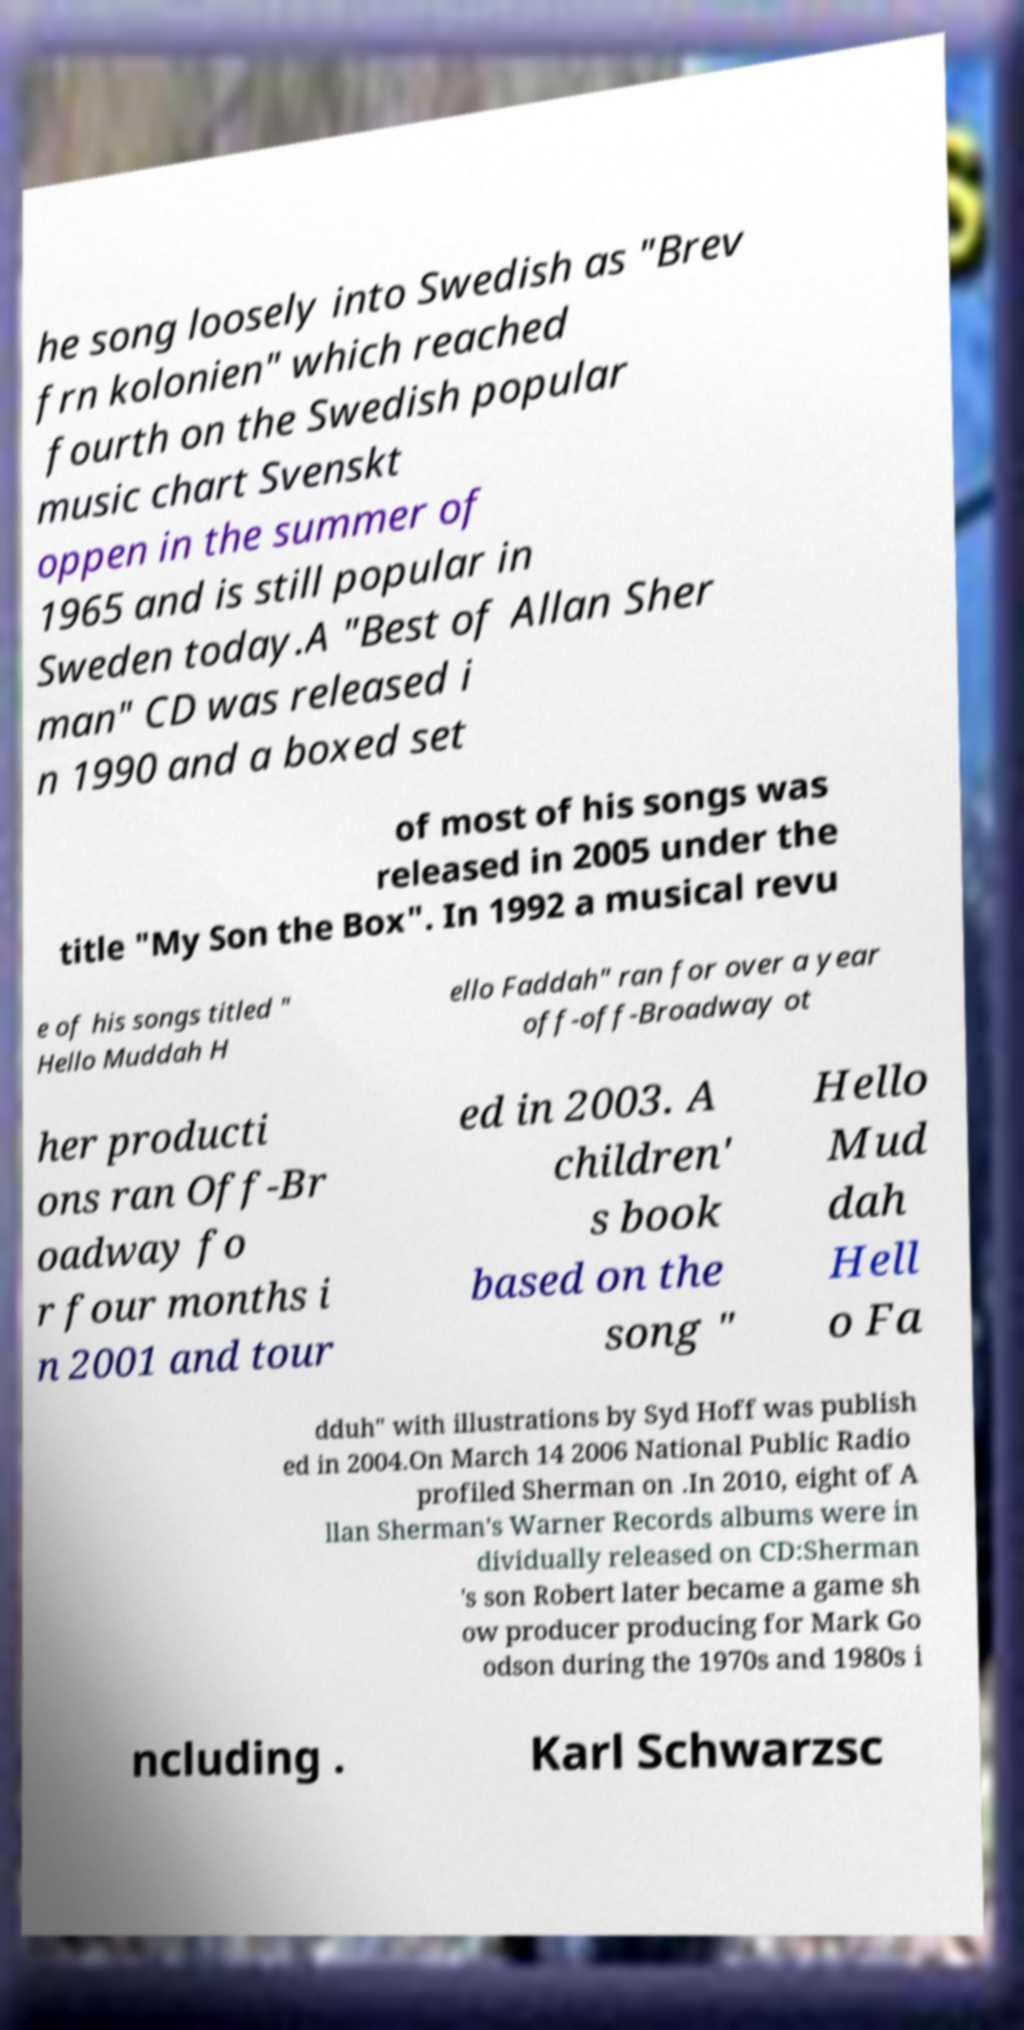Please read and relay the text visible in this image. What does it say? he song loosely into Swedish as "Brev frn kolonien" which reached fourth on the Swedish popular music chart Svenskt oppen in the summer of 1965 and is still popular in Sweden today.A "Best of Allan Sher man" CD was released i n 1990 and a boxed set of most of his songs was released in 2005 under the title "My Son the Box". In 1992 a musical revu e of his songs titled " Hello Muddah H ello Faddah" ran for over a year off-off-Broadway ot her producti ons ran Off-Br oadway fo r four months i n 2001 and tour ed in 2003. A children' s book based on the song " Hello Mud dah Hell o Fa dduh" with illustrations by Syd Hoff was publish ed in 2004.On March 14 2006 National Public Radio profiled Sherman on .In 2010, eight of A llan Sherman's Warner Records albums were in dividually released on CD:Sherman 's son Robert later became a game sh ow producer producing for Mark Go odson during the 1970s and 1980s i ncluding . Karl Schwarzsc 